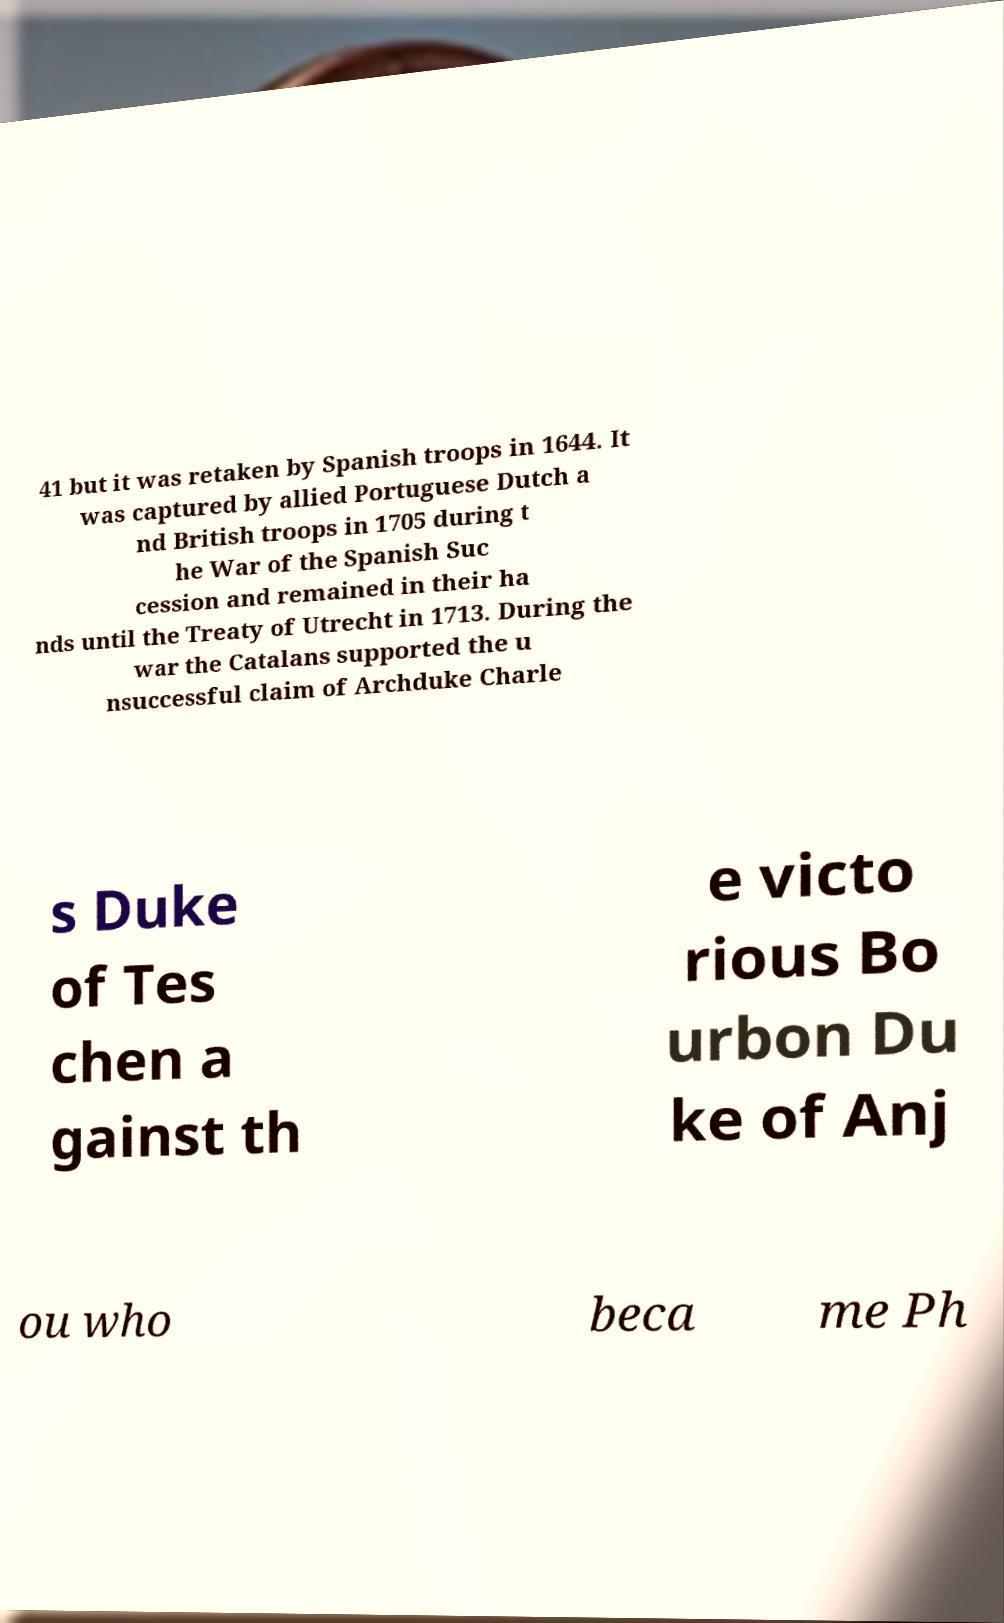Can you read and provide the text displayed in the image?This photo seems to have some interesting text. Can you extract and type it out for me? 41 but it was retaken by Spanish troops in 1644. It was captured by allied Portuguese Dutch a nd British troops in 1705 during t he War of the Spanish Suc cession and remained in their ha nds until the Treaty of Utrecht in 1713. During the war the Catalans supported the u nsuccessful claim of Archduke Charle s Duke of Tes chen a gainst th e victo rious Bo urbon Du ke of Anj ou who beca me Ph 